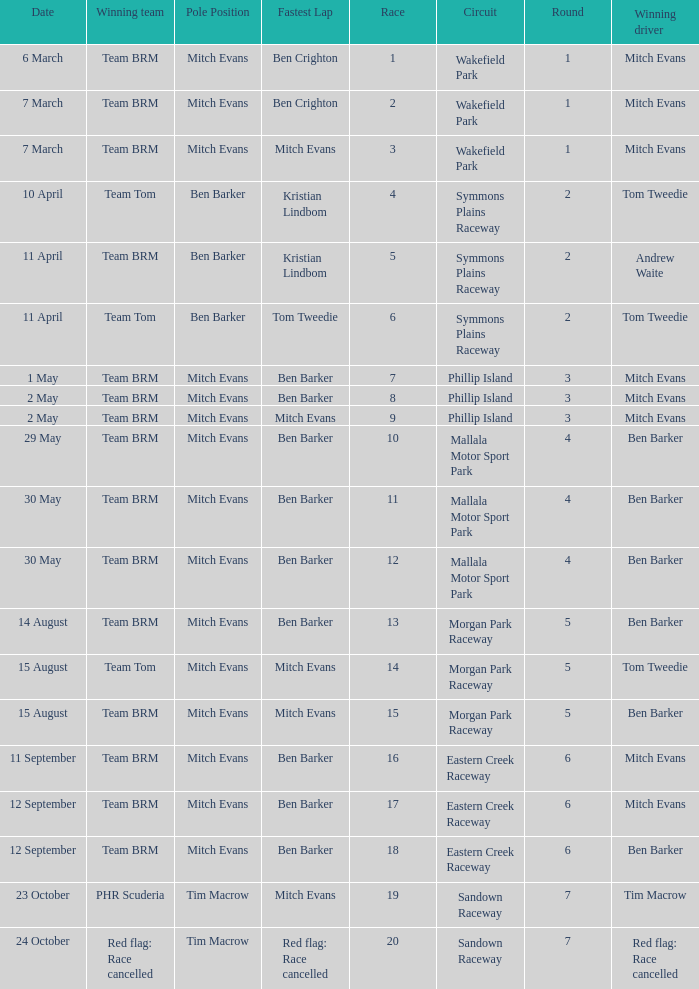What team won Race 17? Team BRM. 